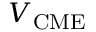Convert formula to latex. <formula><loc_0><loc_0><loc_500><loc_500>V _ { C M E }</formula> 